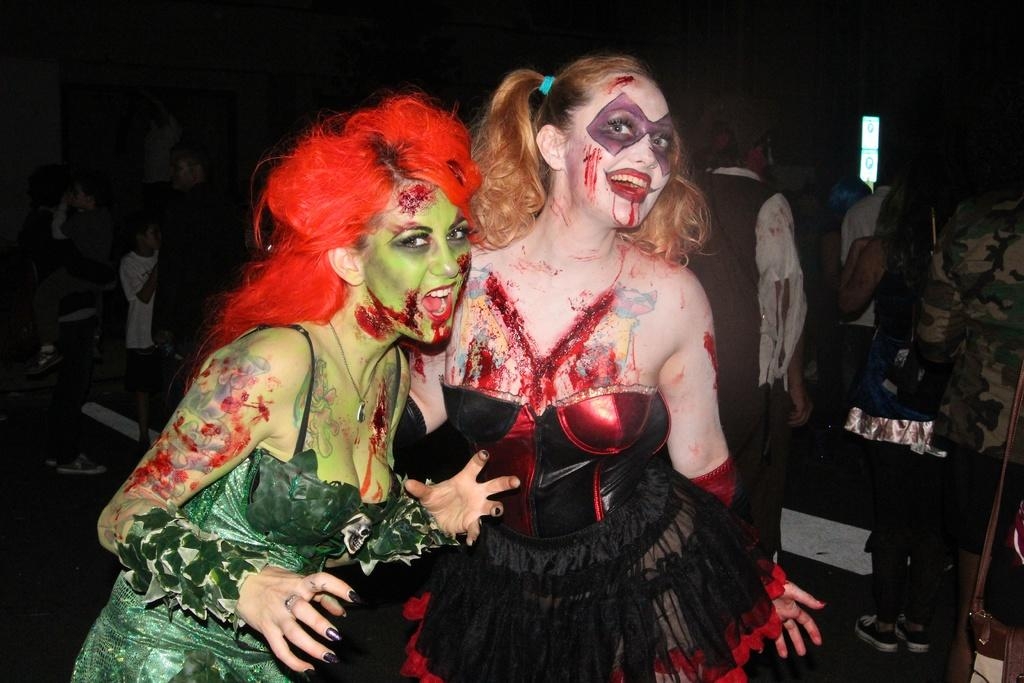How many women are in the image? There are two women in the image. What colors are the women's dresses? The women are wearing black and green color dresses. What type of makeup do the women have on? The women have Halloween makeup. Can you describe the people in the background of the image? There are people standing in the background of the image. What is the wax limit for the candles in the image? There are no candles present in the image, so it is not possible to determine the wax limit for any candles. 